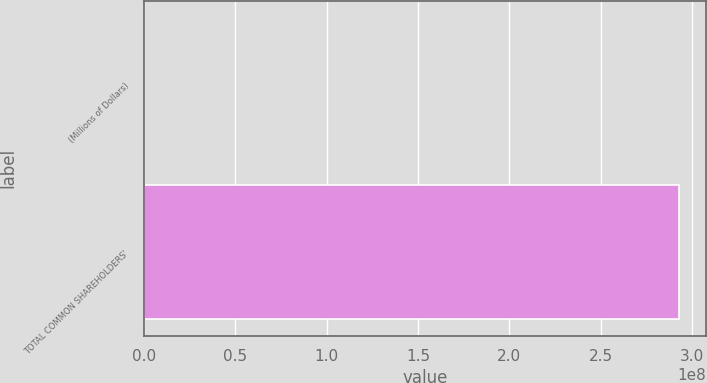<chart> <loc_0><loc_0><loc_500><loc_500><bar_chart><fcel>(Millions of Dollars)<fcel>TOTAL COMMON SHAREHOLDERS'<nl><fcel>2013<fcel>2.92872e+08<nl></chart> 